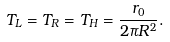Convert formula to latex. <formula><loc_0><loc_0><loc_500><loc_500>T _ { L } = T _ { R } = T _ { H } = \frac { r _ { 0 } } { 2 \pi R ^ { 2 } } .</formula> 